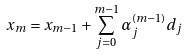Convert formula to latex. <formula><loc_0><loc_0><loc_500><loc_500>x _ { m } = x _ { m - 1 } + \sum _ { j = 0 } ^ { m - 1 } \alpha _ { j } ^ { ( m - 1 ) } d _ { j }</formula> 